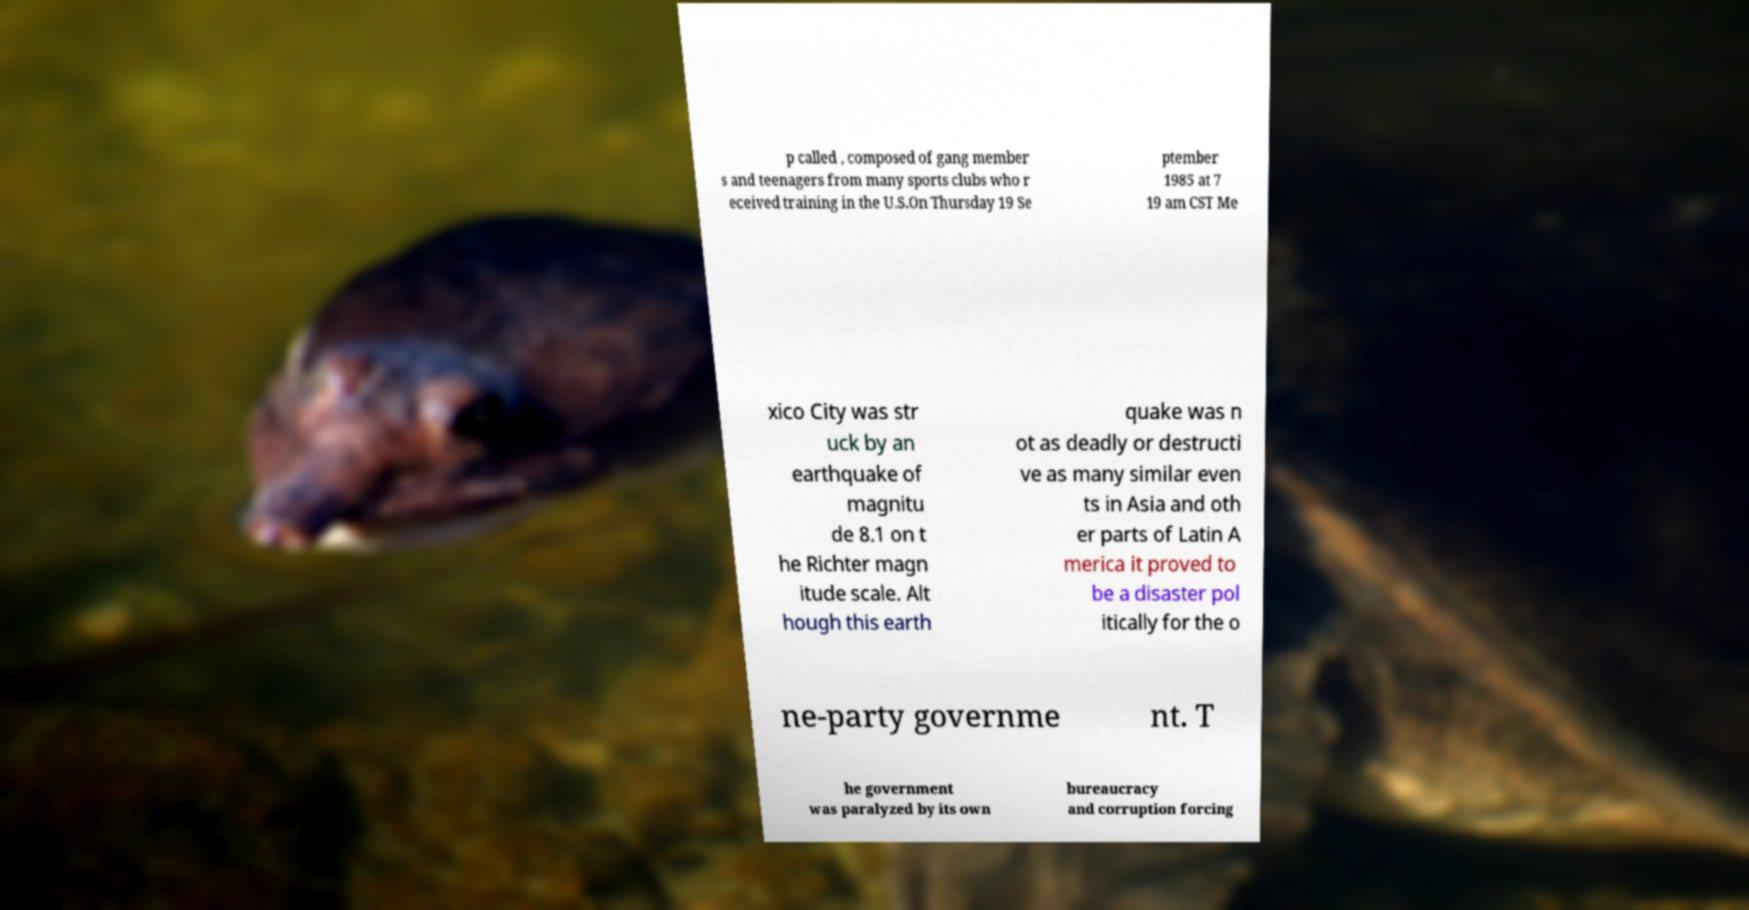Please identify and transcribe the text found in this image. p called , composed of gang member s and teenagers from many sports clubs who r eceived training in the U.S.On Thursday 19 Se ptember 1985 at 7 19 am CST Me xico City was str uck by an earthquake of magnitu de 8.1 on t he Richter magn itude scale. Alt hough this earth quake was n ot as deadly or destructi ve as many similar even ts in Asia and oth er parts of Latin A merica it proved to be a disaster pol itically for the o ne-party governme nt. T he government was paralyzed by its own bureaucracy and corruption forcing 